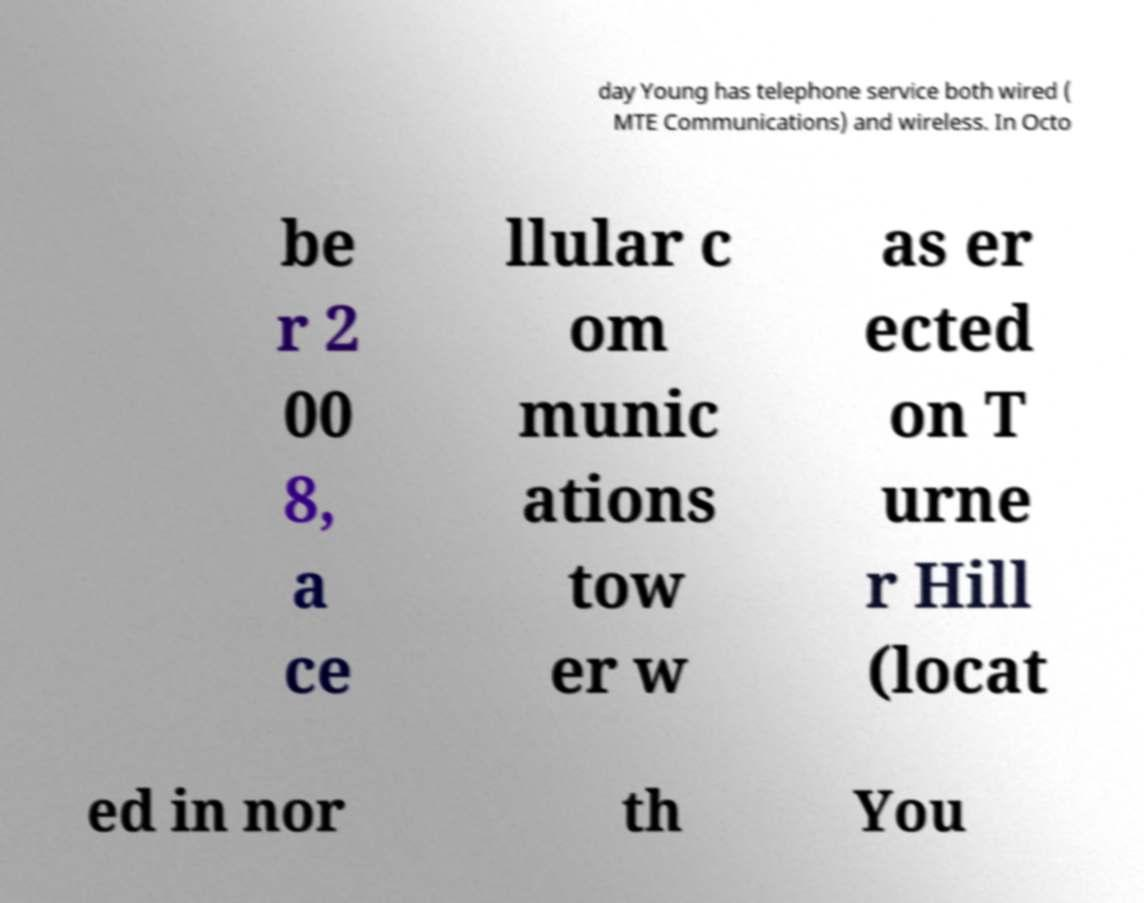Could you assist in decoding the text presented in this image and type it out clearly? day Young has telephone service both wired ( MTE Communications) and wireless. In Octo be r 2 00 8, a ce llular c om munic ations tow er w as er ected on T urne r Hill (locat ed in nor th You 